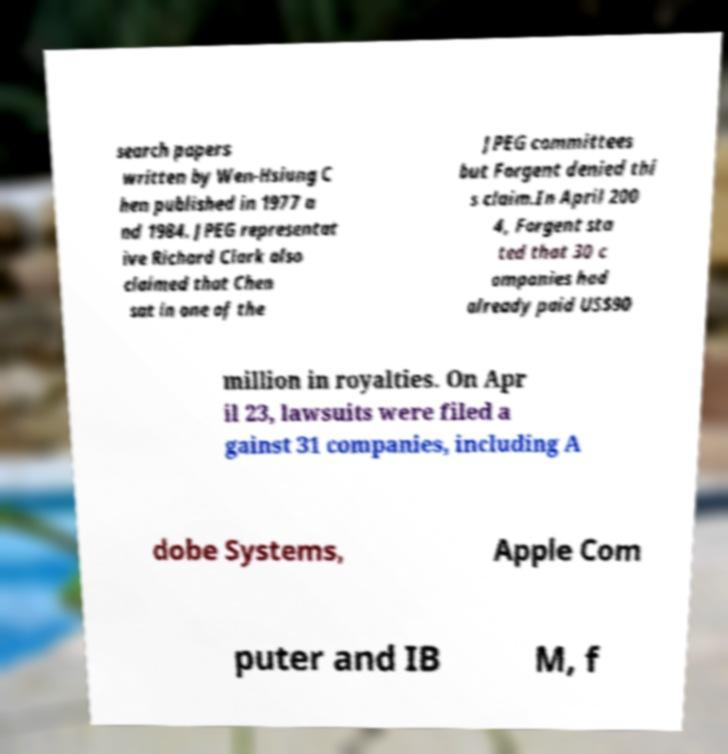Please read and relay the text visible in this image. What does it say? search papers written by Wen-Hsiung C hen published in 1977 a nd 1984. JPEG representat ive Richard Clark also claimed that Chen sat in one of the JPEG committees but Forgent denied thi s claim.In April 200 4, Forgent sta ted that 30 c ompanies had already paid US$90 million in royalties. On Apr il 23, lawsuits were filed a gainst 31 companies, including A dobe Systems, Apple Com puter and IB M, f 